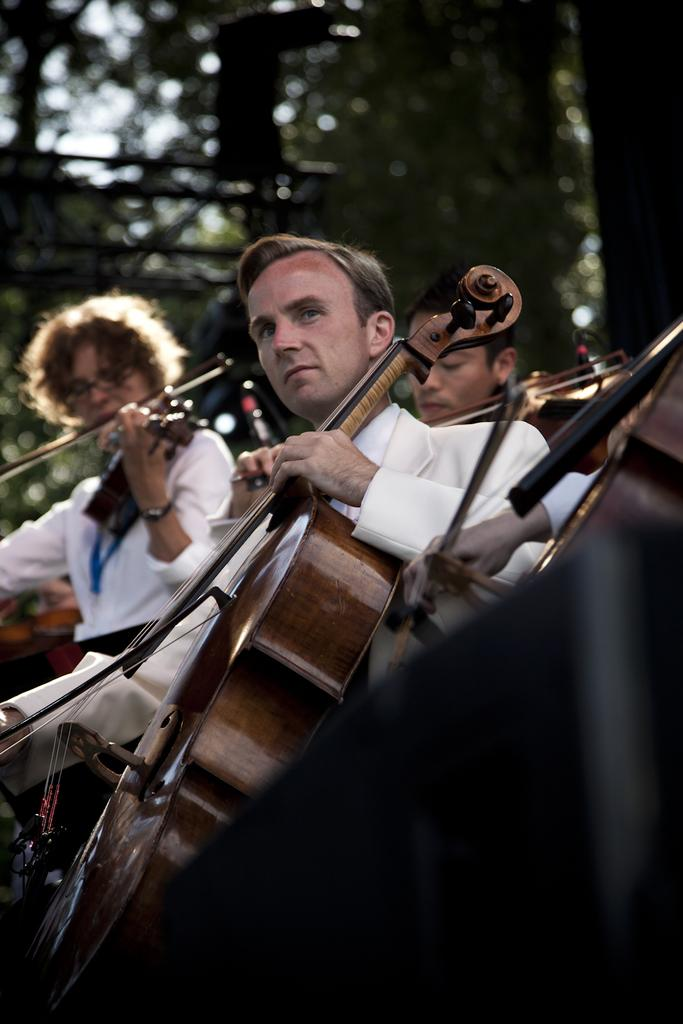How many people are present in the image? There are four people in the image. What are the people doing in the image? The people are playing musical instruments. What can be seen in the background of the image? There are trees visible in the background of the image. What scientific experiment is being conducted in the image? There is no scientific experiment present in the image; it features four people playing musical instruments. 